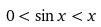Convert formula to latex. <formula><loc_0><loc_0><loc_500><loc_500>0 < \sin x < x</formula> 